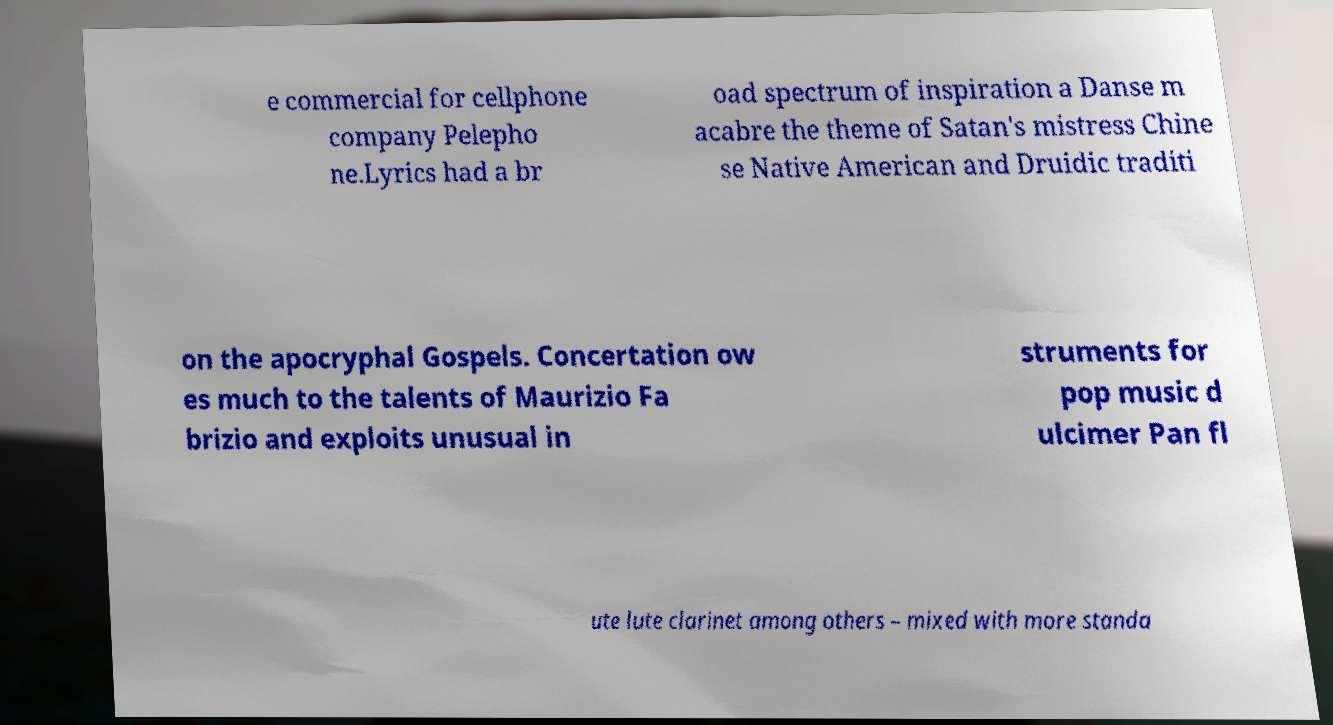Please read and relay the text visible in this image. What does it say? e commercial for cellphone company Pelepho ne.Lyrics had a br oad spectrum of inspiration a Danse m acabre the theme of Satan's mistress Chine se Native American and Druidic traditi on the apocryphal Gospels. Concertation ow es much to the talents of Maurizio Fa brizio and exploits unusual in struments for pop music d ulcimer Pan fl ute lute clarinet among others – mixed with more standa 